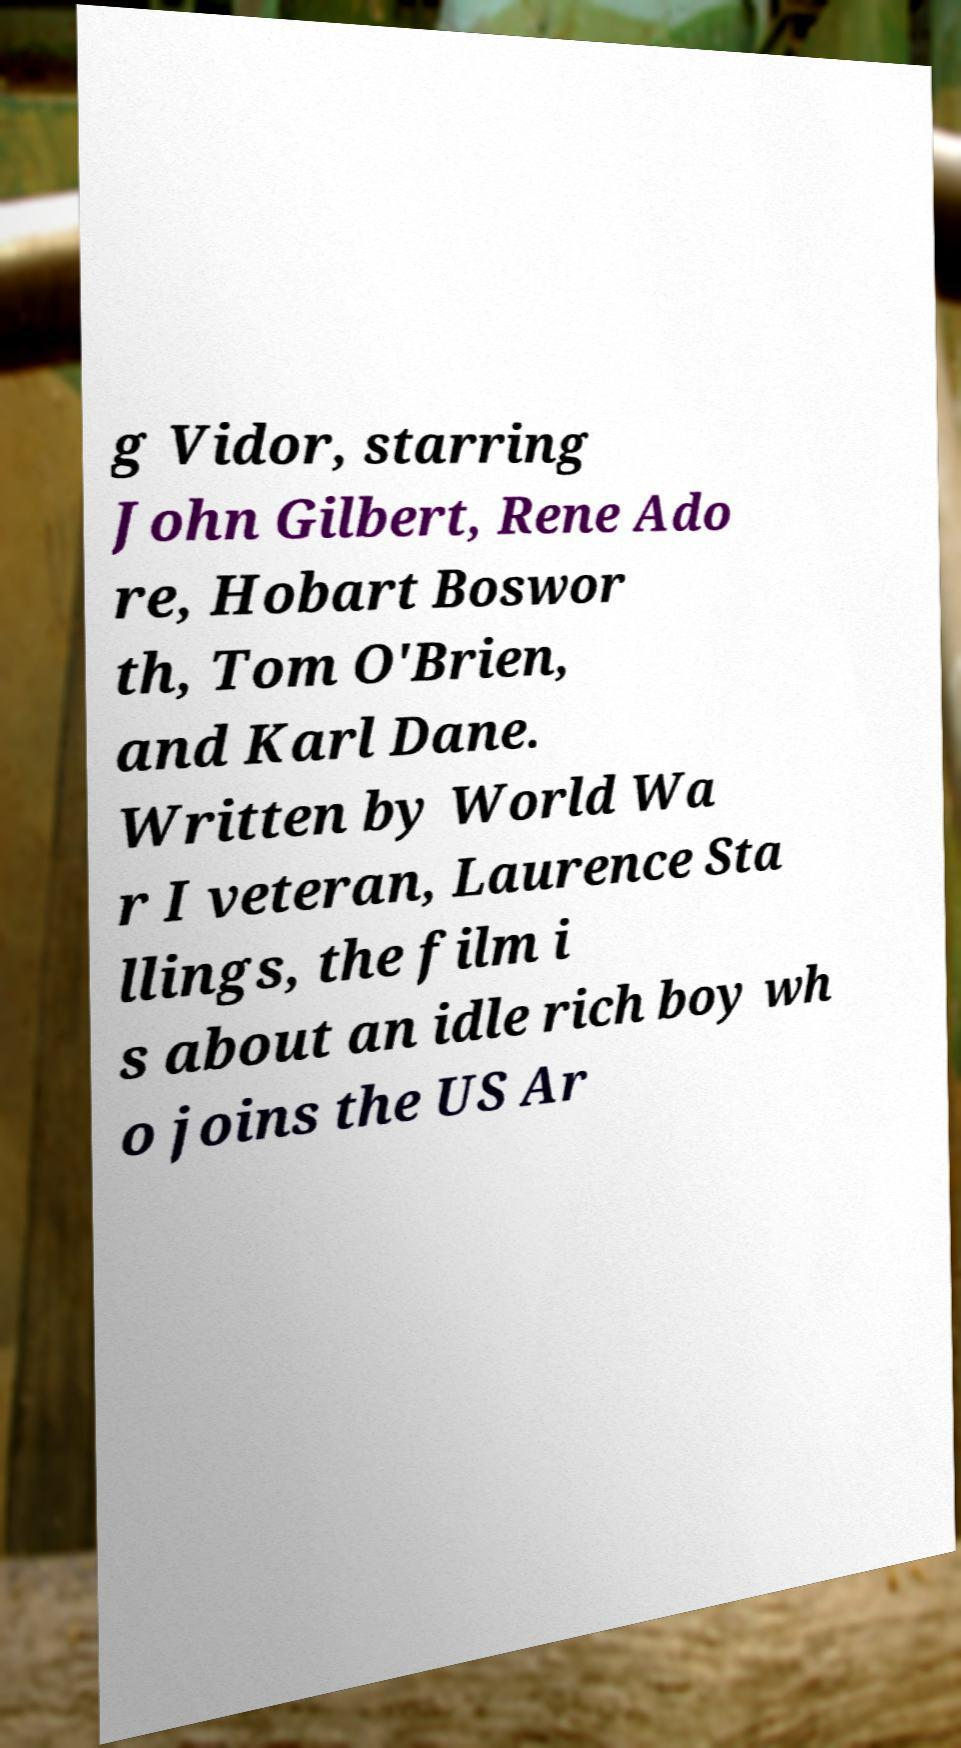Please identify and transcribe the text found in this image. g Vidor, starring John Gilbert, Rene Ado re, Hobart Boswor th, Tom O'Brien, and Karl Dane. Written by World Wa r I veteran, Laurence Sta llings, the film i s about an idle rich boy wh o joins the US Ar 